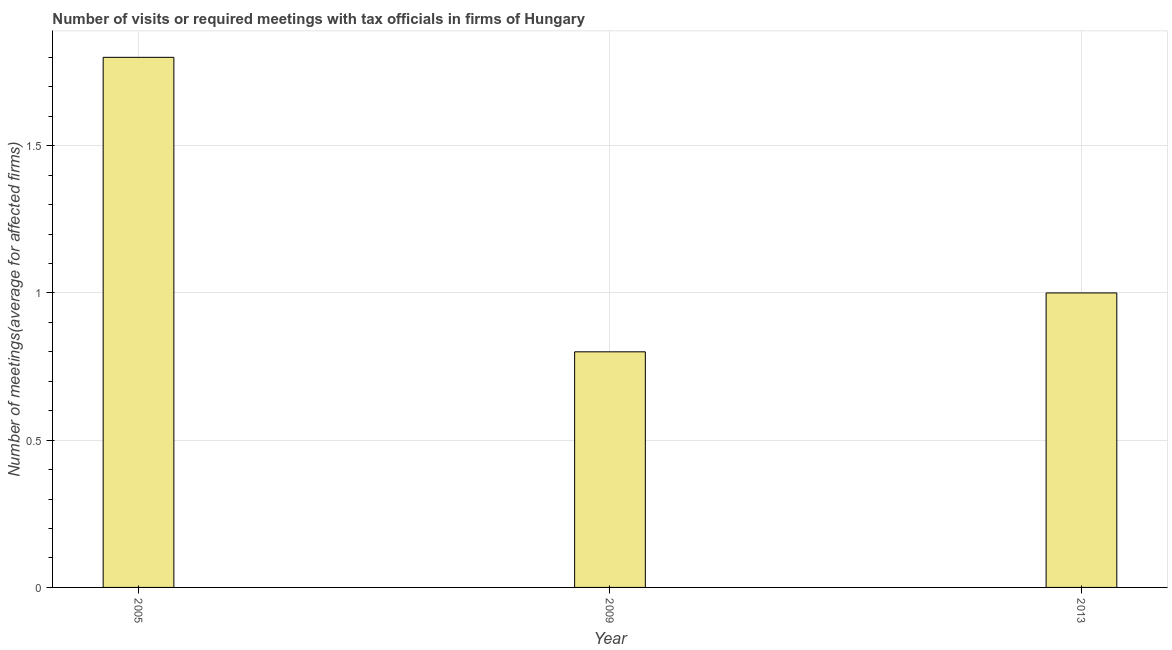Does the graph contain grids?
Your response must be concise. Yes. What is the title of the graph?
Your answer should be compact. Number of visits or required meetings with tax officials in firms of Hungary. What is the label or title of the Y-axis?
Your answer should be very brief. Number of meetings(average for affected firms). What is the number of required meetings with tax officials in 2005?
Keep it short and to the point. 1.8. Across all years, what is the maximum number of required meetings with tax officials?
Your answer should be compact. 1.8. In which year was the number of required meetings with tax officials minimum?
Your answer should be very brief. 2009. What is the average number of required meetings with tax officials per year?
Provide a succinct answer. 1.2. In how many years, is the number of required meetings with tax officials greater than 0.9 ?
Your response must be concise. 2. What is the ratio of the number of required meetings with tax officials in 2009 to that in 2013?
Your response must be concise. 0.8. Is the number of required meetings with tax officials in 2009 less than that in 2013?
Give a very brief answer. Yes. Is the difference between the number of required meetings with tax officials in 2005 and 2009 greater than the difference between any two years?
Provide a succinct answer. Yes. What is the difference between the highest and the second highest number of required meetings with tax officials?
Your answer should be very brief. 0.8. Is the sum of the number of required meetings with tax officials in 2009 and 2013 greater than the maximum number of required meetings with tax officials across all years?
Keep it short and to the point. No. How many bars are there?
Your answer should be compact. 3. What is the difference between two consecutive major ticks on the Y-axis?
Your answer should be very brief. 0.5. Are the values on the major ticks of Y-axis written in scientific E-notation?
Ensure brevity in your answer.  No. What is the Number of meetings(average for affected firms) in 2005?
Offer a very short reply. 1.8. What is the Number of meetings(average for affected firms) of 2009?
Provide a succinct answer. 0.8. What is the Number of meetings(average for affected firms) of 2013?
Your answer should be very brief. 1. What is the difference between the Number of meetings(average for affected firms) in 2005 and 2009?
Make the answer very short. 1. What is the ratio of the Number of meetings(average for affected firms) in 2005 to that in 2009?
Ensure brevity in your answer.  2.25. 